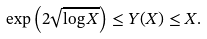Convert formula to latex. <formula><loc_0><loc_0><loc_500><loc_500>\exp \left ( 2 \sqrt { \log X } \right ) \leq Y ( X ) \leq X .</formula> 